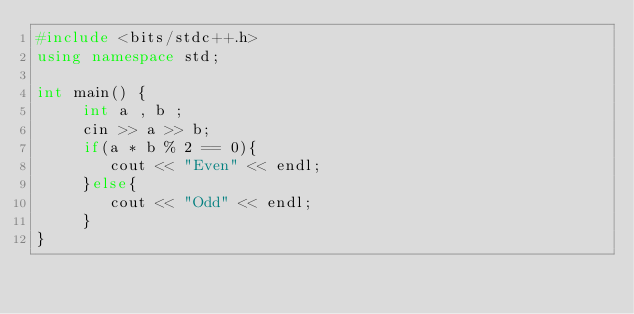<code> <loc_0><loc_0><loc_500><loc_500><_C++_>#include <bits/stdc++.h>
using namespace std;

int main() {
	 int a , b ;
  	 cin >> a >> b;
     if(a * b % 2 == 0){
     	cout << "Even" << endl;
     }else{
     	cout << "Odd" << endl;
     }
}
</code> 